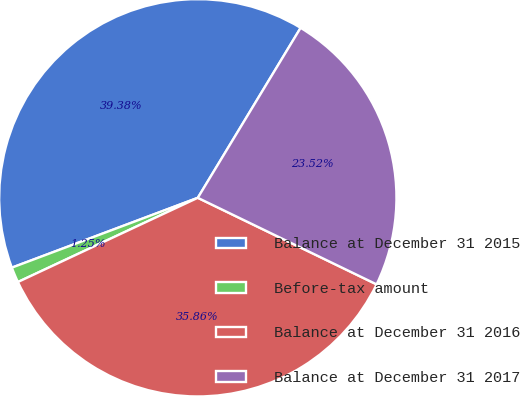<chart> <loc_0><loc_0><loc_500><loc_500><pie_chart><fcel>Balance at December 31 2015<fcel>Before-tax amount<fcel>Balance at December 31 2016<fcel>Balance at December 31 2017<nl><fcel>39.38%<fcel>1.25%<fcel>35.86%<fcel>23.52%<nl></chart> 